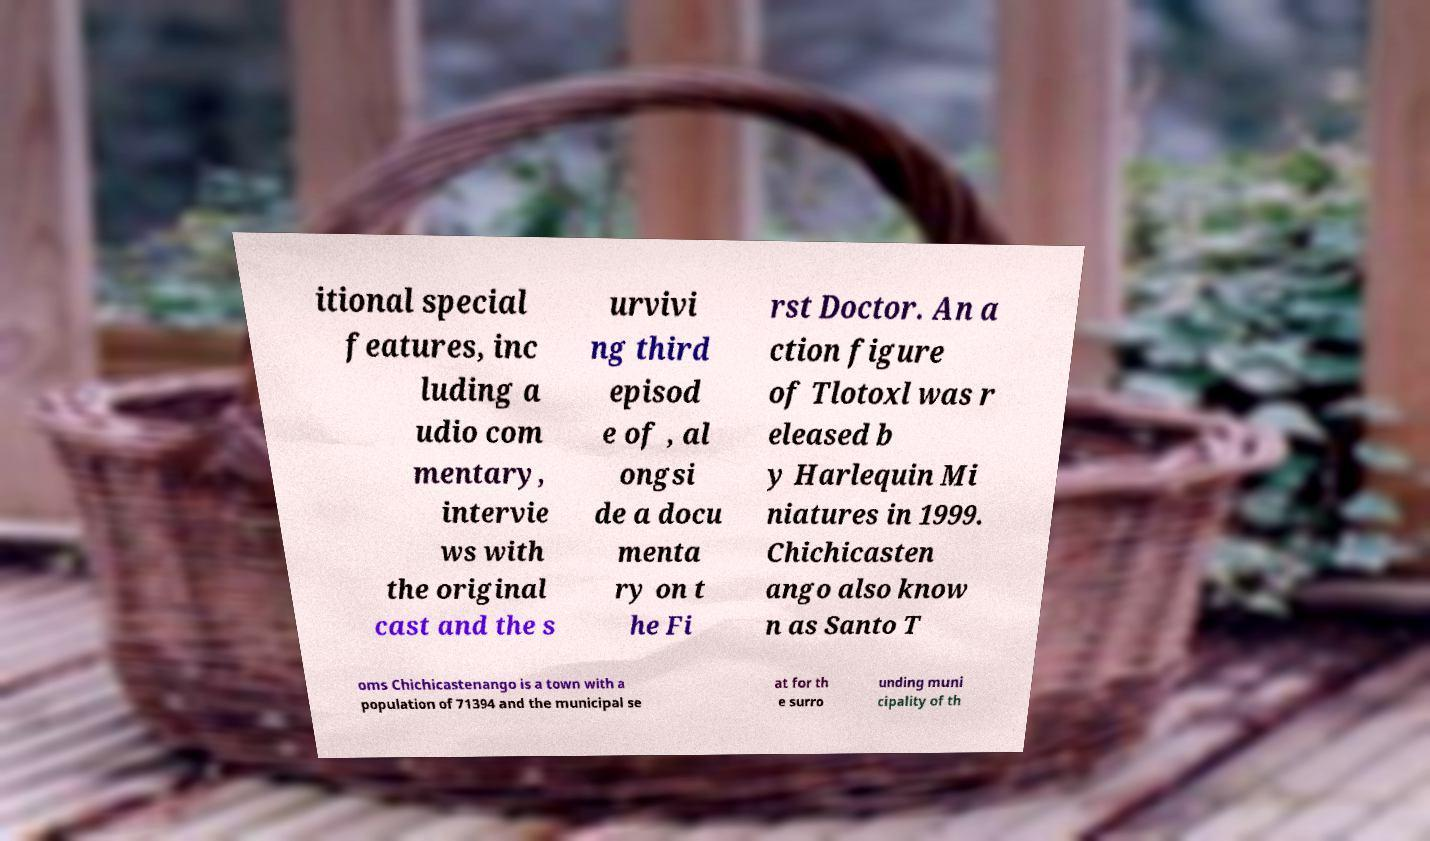Could you assist in decoding the text presented in this image and type it out clearly? itional special features, inc luding a udio com mentary, intervie ws with the original cast and the s urvivi ng third episod e of , al ongsi de a docu menta ry on t he Fi rst Doctor. An a ction figure of Tlotoxl was r eleased b y Harlequin Mi niatures in 1999. Chichicasten ango also know n as Santo T oms Chichicastenango is a town with a population of 71394 and the municipal se at for th e surro unding muni cipality of th 